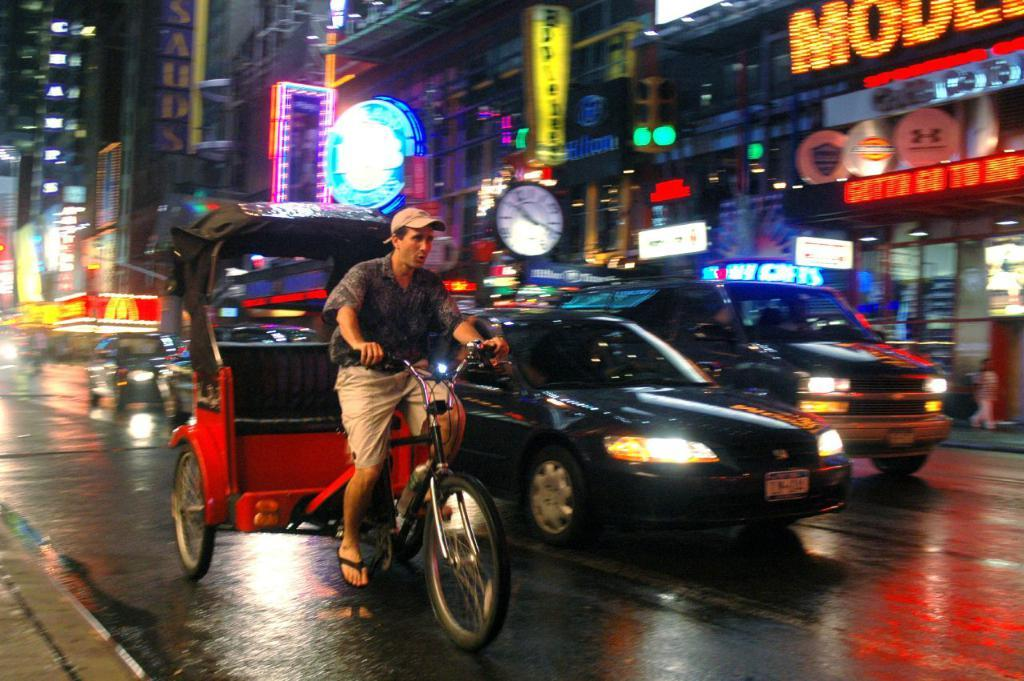<image>
Give a short and clear explanation of the subsequent image. Cars and a pedi cab are on the street and they just passed McDonald's. 